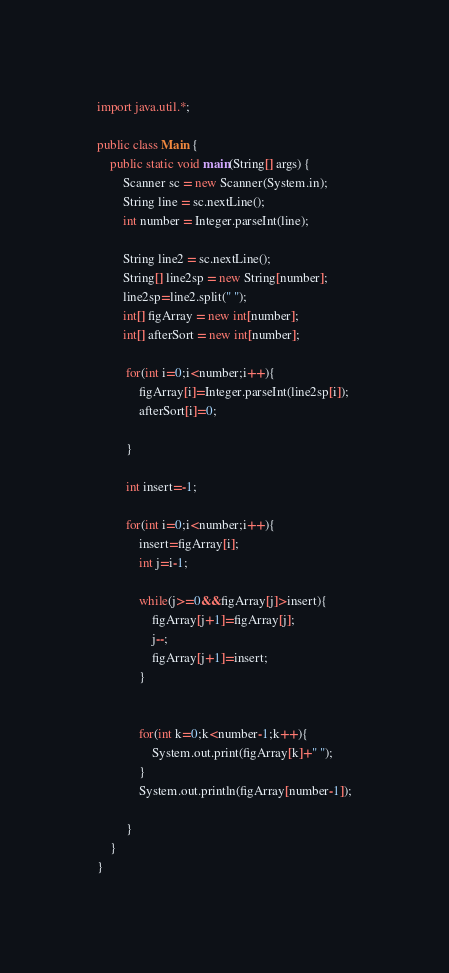<code> <loc_0><loc_0><loc_500><loc_500><_Java_>import java.util.*;

public class Main {
    public static void main(String[] args) {
    	Scanner sc = new Scanner(System.in);
        String line = sc.nextLine();
        int number = Integer.parseInt(line);
        
        String line2 = sc.nextLine();
        String[] line2sp = new String[number];
    	line2sp=line2.split(" ");
    	int[] figArray = new int[number];
    	int[] afterSort = new int[number];
    	
    	 for(int i=0;i<number;i++){
    		 figArray[i]=Integer.parseInt(line2sp[i]);
    		 afterSort[i]=0;
    		 
         }    	 
    	 
    	 int insert=-1;
    	 
    	 for(int i=0;i<number;i++){
    		 insert=figArray[i];
    		 int j=i-1;
    		 
    		 while(j>=0&&figArray[j]>insert){
    			 figArray[j+1]=figArray[j];
    			 j--;
    			 figArray[j+1]=insert;
    		 }
    		 
    		 
    		 for(int k=0;k<number-1;k++){
    			 System.out.print(figArray[k]+" ");
    		 }
    		 System.out.println(figArray[number-1]);
    		 
    	 }
    }   
}</code> 